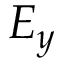<formula> <loc_0><loc_0><loc_500><loc_500>E _ { y }</formula> 